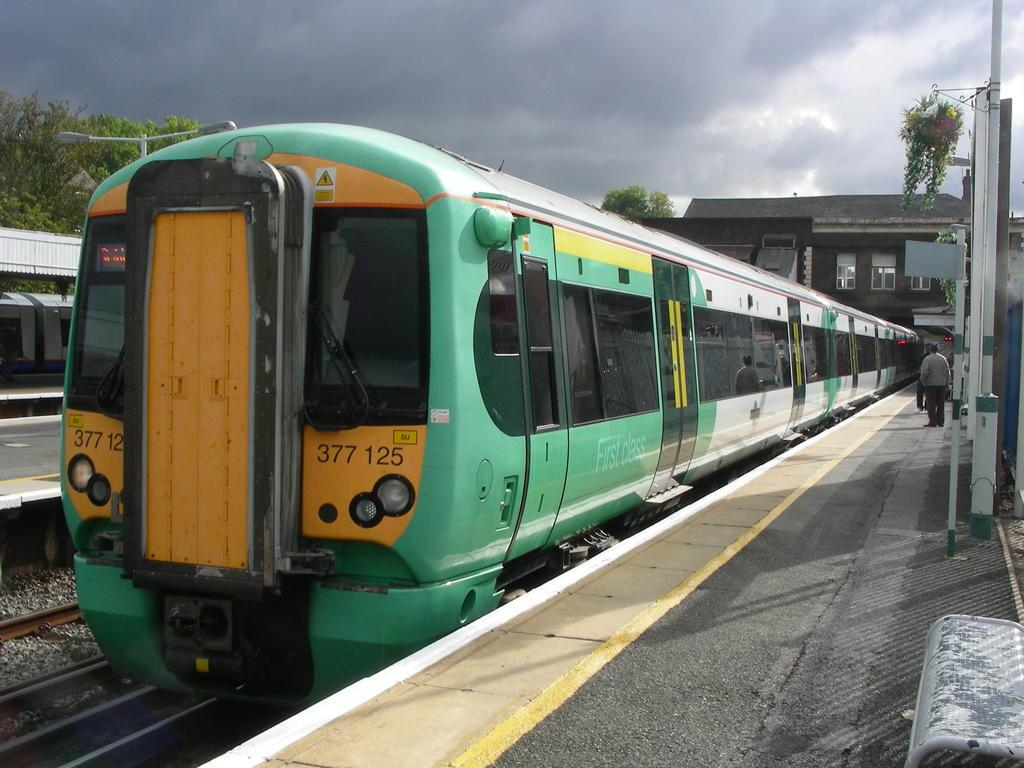<image>
Relay a brief, clear account of the picture shown. A green and yellow passenger train, with the number 377 125 on the front, is parked at the train station. 